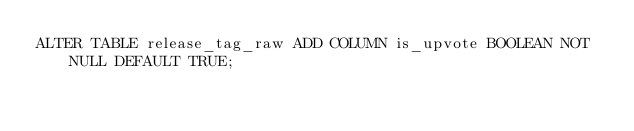Convert code to text. <code><loc_0><loc_0><loc_500><loc_500><_SQL_>ALTER TABLE release_tag_raw ADD COLUMN is_upvote BOOLEAN NOT NULL DEFAULT TRUE;</code> 